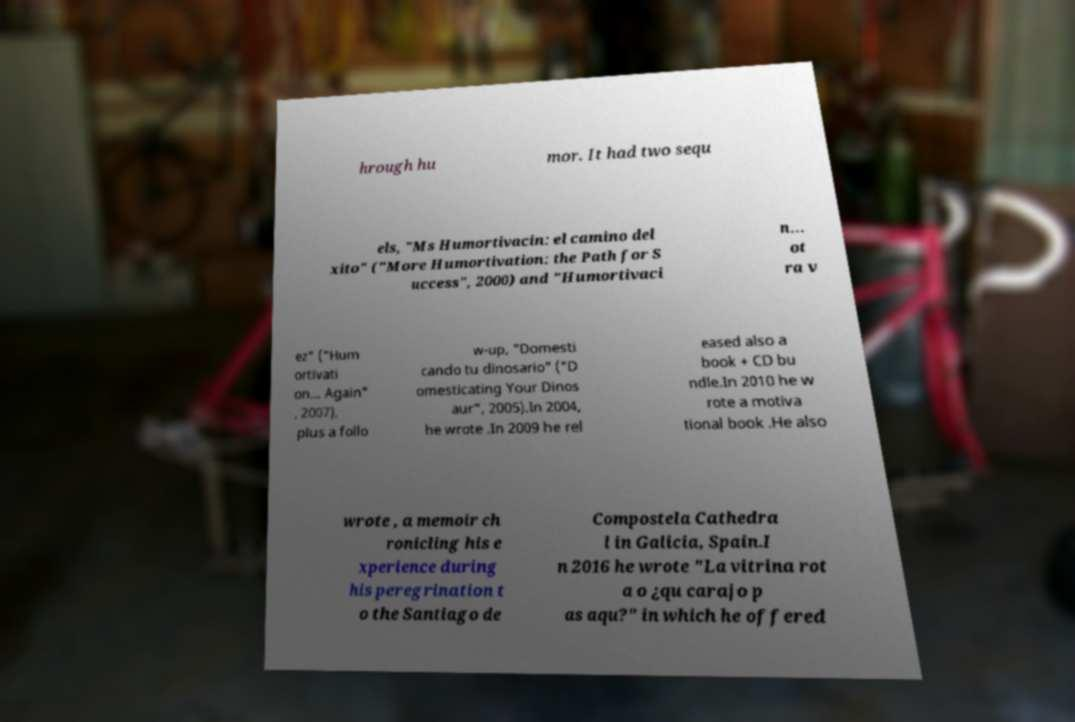What messages or text are displayed in this image? I need them in a readable, typed format. hrough hu mor. It had two sequ els, "Ms Humortivacin: el camino del xito" ("More Humortivation: the Path for S uccess", 2000) and "Humortivaci n… ot ra v ez" ("Hum ortivati on… Again" , 2007), plus a follo w-up, "Domesti cando tu dinosario" ("D omesticating Your Dinos aur", 2005).In 2004, he wrote .In 2009 he rel eased also a book + CD bu ndle.In 2010 he w rote a motiva tional book .He also wrote , a memoir ch ronicling his e xperience during his peregrination t o the Santiago de Compostela Cathedra l in Galicia, Spain.I n 2016 he wrote "La vitrina rot a o ¿qu carajo p as aqu?" in which he offered 